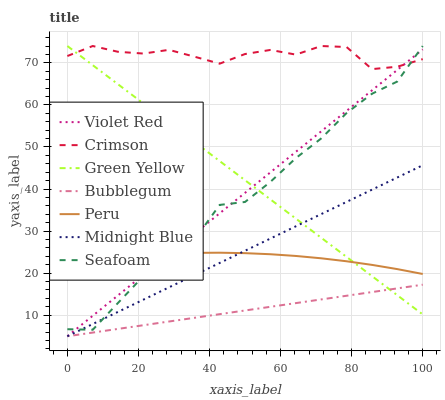Does Midnight Blue have the minimum area under the curve?
Answer yes or no. No. Does Midnight Blue have the maximum area under the curve?
Answer yes or no. No. Is Midnight Blue the smoothest?
Answer yes or no. No. Is Midnight Blue the roughest?
Answer yes or no. No. Does Seafoam have the lowest value?
Answer yes or no. No. Does Midnight Blue have the highest value?
Answer yes or no. No. Is Midnight Blue less than Crimson?
Answer yes or no. Yes. Is Crimson greater than Midnight Blue?
Answer yes or no. Yes. Does Midnight Blue intersect Crimson?
Answer yes or no. No. 